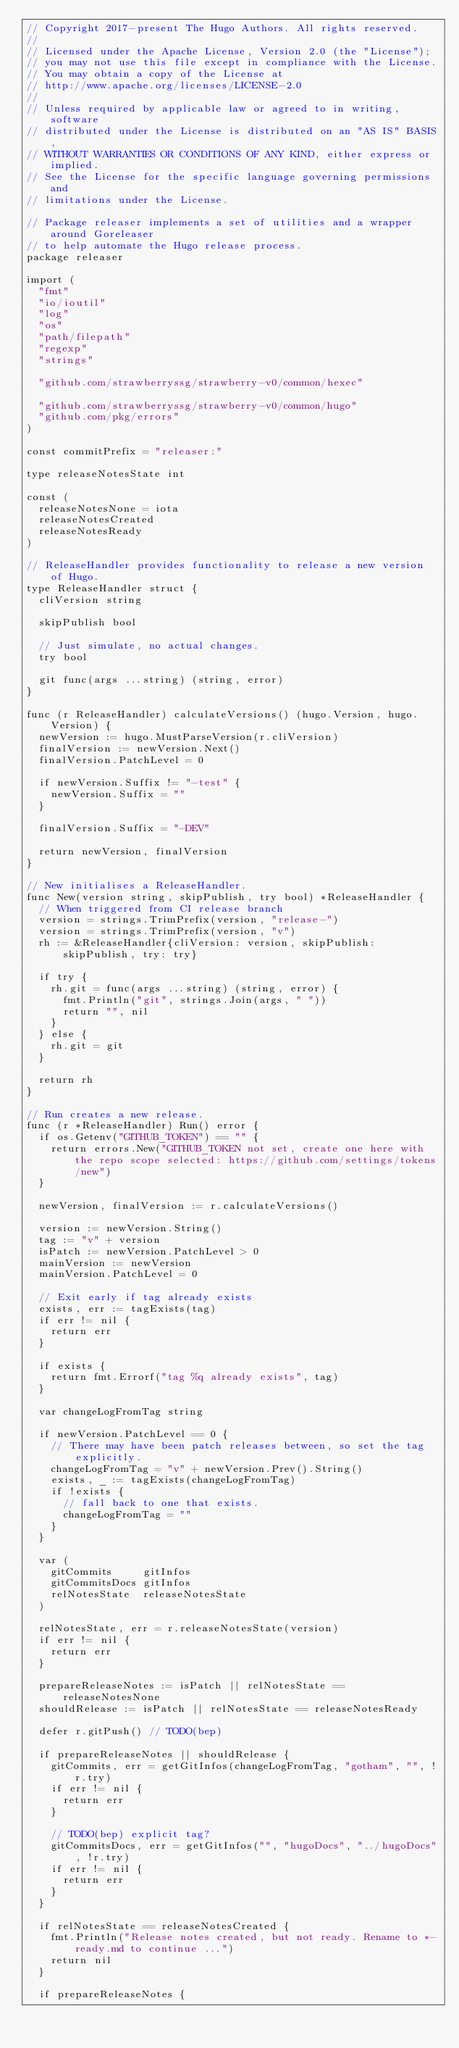Convert code to text. <code><loc_0><loc_0><loc_500><loc_500><_Go_>// Copyright 2017-present The Hugo Authors. All rights reserved.
//
// Licensed under the Apache License, Version 2.0 (the "License");
// you may not use this file except in compliance with the License.
// You may obtain a copy of the License at
// http://www.apache.org/licenses/LICENSE-2.0
//
// Unless required by applicable law or agreed to in writing, software
// distributed under the License is distributed on an "AS IS" BASIS,
// WITHOUT WARRANTIES OR CONDITIONS OF ANY KIND, either express or implied.
// See the License for the specific language governing permissions and
// limitations under the License.

// Package releaser implements a set of utilities and a wrapper around Goreleaser
// to help automate the Hugo release process.
package releaser

import (
	"fmt"
	"io/ioutil"
	"log"
	"os"
	"path/filepath"
	"regexp"
	"strings"

	"github.com/strawberryssg/strawberry-v0/common/hexec"

	"github.com/strawberryssg/strawberry-v0/common/hugo"
	"github.com/pkg/errors"
)

const commitPrefix = "releaser:"

type releaseNotesState int

const (
	releaseNotesNone = iota
	releaseNotesCreated
	releaseNotesReady
)

// ReleaseHandler provides functionality to release a new version of Hugo.
type ReleaseHandler struct {
	cliVersion string

	skipPublish bool

	// Just simulate, no actual changes.
	try bool

	git func(args ...string) (string, error)
}

func (r ReleaseHandler) calculateVersions() (hugo.Version, hugo.Version) {
	newVersion := hugo.MustParseVersion(r.cliVersion)
	finalVersion := newVersion.Next()
	finalVersion.PatchLevel = 0

	if newVersion.Suffix != "-test" {
		newVersion.Suffix = ""
	}

	finalVersion.Suffix = "-DEV"

	return newVersion, finalVersion
}

// New initialises a ReleaseHandler.
func New(version string, skipPublish, try bool) *ReleaseHandler {
	// When triggered from CI release branch
	version = strings.TrimPrefix(version, "release-")
	version = strings.TrimPrefix(version, "v")
	rh := &ReleaseHandler{cliVersion: version, skipPublish: skipPublish, try: try}

	if try {
		rh.git = func(args ...string) (string, error) {
			fmt.Println("git", strings.Join(args, " "))
			return "", nil
		}
	} else {
		rh.git = git
	}

	return rh
}

// Run creates a new release.
func (r *ReleaseHandler) Run() error {
	if os.Getenv("GITHUB_TOKEN") == "" {
		return errors.New("GITHUB_TOKEN not set, create one here with the repo scope selected: https://github.com/settings/tokens/new")
	}

	newVersion, finalVersion := r.calculateVersions()

	version := newVersion.String()
	tag := "v" + version
	isPatch := newVersion.PatchLevel > 0
	mainVersion := newVersion
	mainVersion.PatchLevel = 0

	// Exit early if tag already exists
	exists, err := tagExists(tag)
	if err != nil {
		return err
	}

	if exists {
		return fmt.Errorf("tag %q already exists", tag)
	}

	var changeLogFromTag string

	if newVersion.PatchLevel == 0 {
		// There may have been patch releases between, so set the tag explicitly.
		changeLogFromTag = "v" + newVersion.Prev().String()
		exists, _ := tagExists(changeLogFromTag)
		if !exists {
			// fall back to one that exists.
			changeLogFromTag = ""
		}
	}

	var (
		gitCommits     gitInfos
		gitCommitsDocs gitInfos
		relNotesState  releaseNotesState
	)

	relNotesState, err = r.releaseNotesState(version)
	if err != nil {
		return err
	}

	prepareReleaseNotes := isPatch || relNotesState == releaseNotesNone
	shouldRelease := isPatch || relNotesState == releaseNotesReady

	defer r.gitPush() // TODO(bep)

	if prepareReleaseNotes || shouldRelease {
		gitCommits, err = getGitInfos(changeLogFromTag, "gotham", "", !r.try)
		if err != nil {
			return err
		}

		// TODO(bep) explicit tag?
		gitCommitsDocs, err = getGitInfos("", "hugoDocs", "../hugoDocs", !r.try)
		if err != nil {
			return err
		}
	}

	if relNotesState == releaseNotesCreated {
		fmt.Println("Release notes created, but not ready. Rename to *-ready.md to continue ...")
		return nil
	}

	if prepareReleaseNotes {</code> 